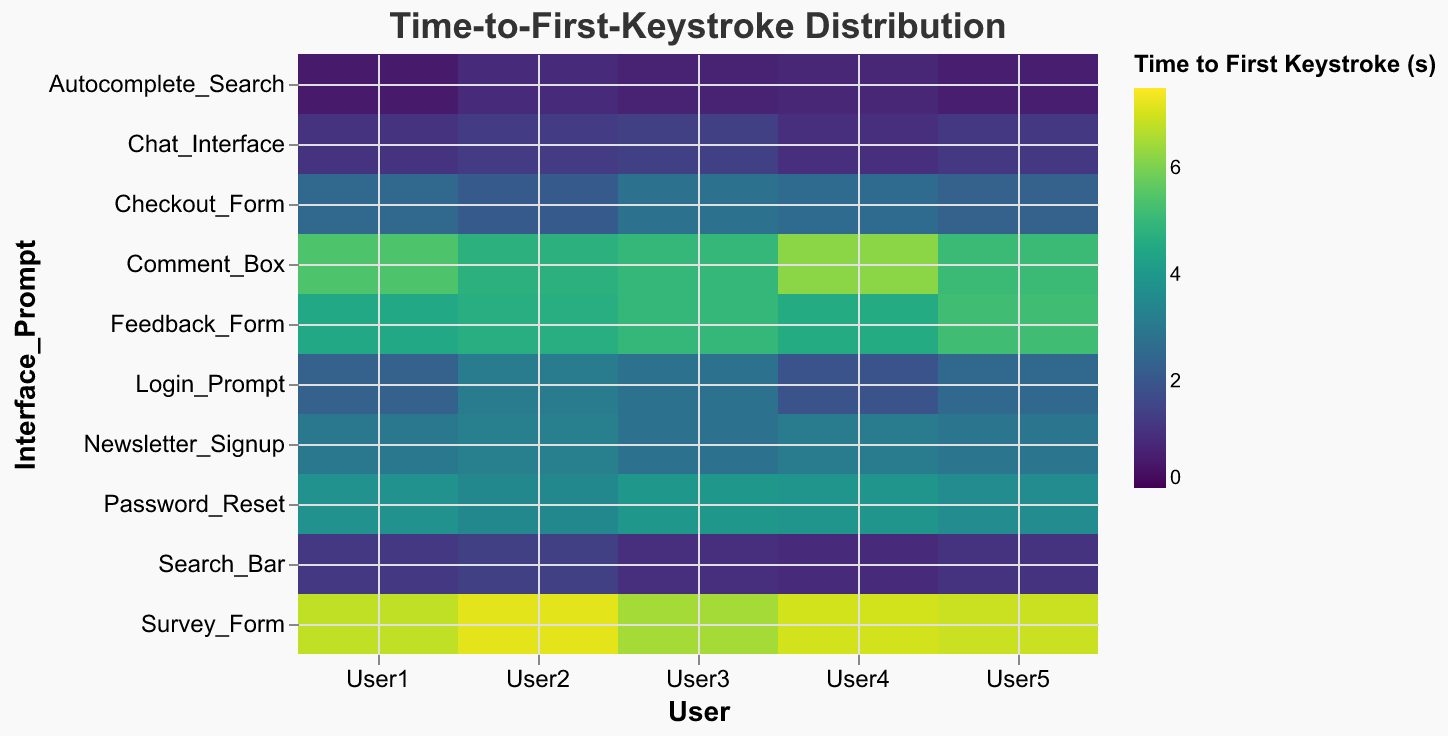What's the title of the figure? The title is typically located at the top of the figure. From the provided code, it specifies the title as "Time-to-First-Keystroke Distribution".
Answer: Time-to-First-Keystroke Distribution Which interface prompt has the highest average time-to-first-keystroke? To determine the average for each interface prompt, sum the times for each user and divide by the number of users (in this case, 5). The Survey_Form has the highest average (6.88 seconds) based on the data calculations provided.
Answer: Survey_Form How does the time-to-first-keystroke for the Autocomplete_Search compare to the Search_Bar? By comparing the values, the Autocomplete_Search has lower times across all users than the Search_Bar, indicating quicker initial responses.
Answer: Autocomplete_Search is quicker Which user took the longest time to provide their first keystroke on the Feedback_Form? Look at the time values for each user under the Feedback_Form prompt. User5 took the longest time with 5.2 seconds.
Answer: User5 What is the color scheme used to represent the time-to-first-keystroke values? According to the code, the color scheme is "viridis", which is commonly used for representing quantitative data.
Answer: Viridis Which interface prompt has the lowest variation in time-to-first-keystroke among users? The variation can be assessed by looking at the range (difference between the highest and lowest times). Autocomplete_Search has the lowest variation since the times are closely packed between 0.5 and 0.9 seconds.
Answer: Autocomplete_Search Calculate the difference in average time-to-first-keystroke between the Comment_Box and Newsletter_Signup. Firstly, calculate the average times: Comment_Box (5.3 sec) and Newsletter_Signup (3.0 sec). The difference is 5.3 - 3.0 = 2.3 seconds.
Answer: 2.3 seconds Which user generally has the fastest time-to-first-keystroke across all prompts? Sum the times for each user across all prompts. User1 has the smallest total time which implies they are generally the fastest.
Answer: User1 Identify the two interface prompts with the closest average times to each other. Calculate and compare the average times. The Checkout_Form and Login_Prompt both average around 2.52 and 2.52 respectively, making them the closest.
Answer: Checkout_Form and Login_Prompt 